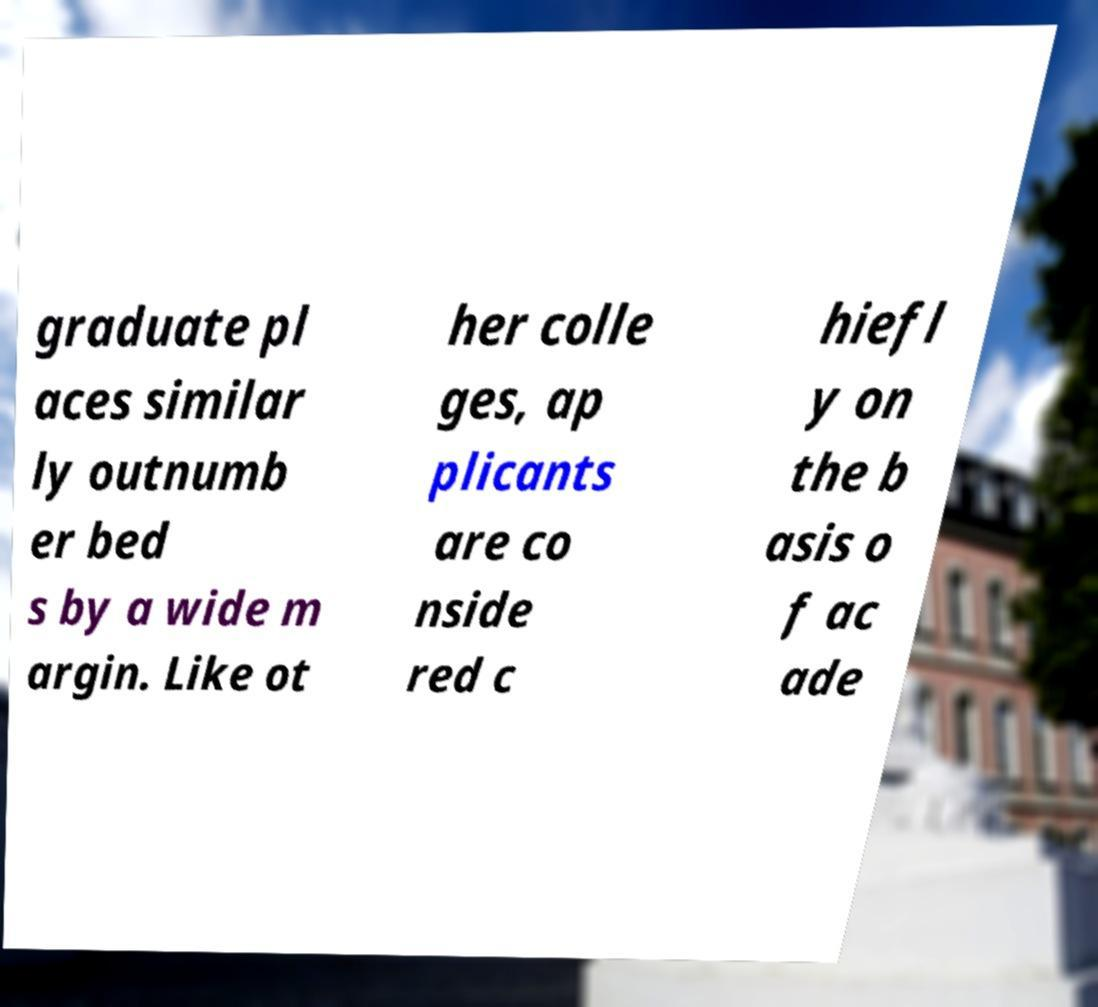Could you extract and type out the text from this image? graduate pl aces similar ly outnumb er bed s by a wide m argin. Like ot her colle ges, ap plicants are co nside red c hiefl y on the b asis o f ac ade 